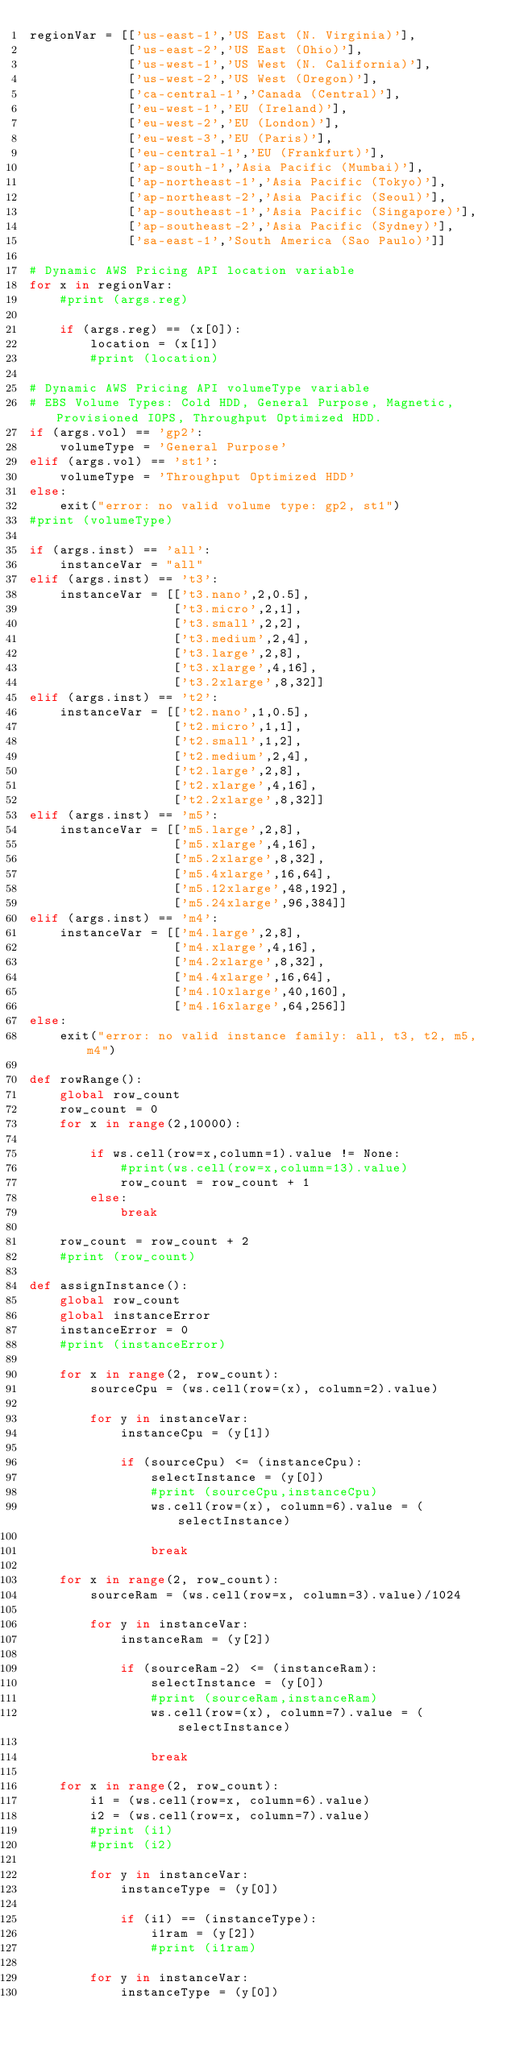<code> <loc_0><loc_0><loc_500><loc_500><_Python_>regionVar = [['us-east-1','US East (N. Virginia)'],
			 ['us-east-2','US East (Ohio)'],
			 ['us-west-1','US West (N. California)'],
			 ['us-west-2','US West (Oregon)'],
			 ['ca-central-1','Canada (Central)'],
			 ['eu-west-1','EU (Ireland)'],
			 ['eu-west-2','EU (London)'],
			 ['eu-west-3','EU (Paris)'],
			 ['eu-central-1','EU (Frankfurt)'],
			 ['ap-south-1','Asia Pacific (Mumbai)'],
			 ['ap-northeast-1','Asia Pacific (Tokyo)'],
			 ['ap-northeast-2','Asia Pacific (Seoul)'],
			 ['ap-southeast-1','Asia Pacific (Singapore)'],
			 ['ap-southeast-2','Asia Pacific (Sydney)'],
			 ['sa-east-1','South America (Sao Paulo)']]

# Dynamic AWS Pricing API location variable
for x in regionVar:
	#print (args.reg)	
	
	if (args.reg) == (x[0]):
		location = (x[1])
		#print (location)
	
# Dynamic AWS Pricing API volumeType variable  
# EBS Volume Types: Cold HDD, General Purpose, Magnetic, Provisioned IOPS, Throughput Optimized HDD.
if (args.vol) == 'gp2':						
	volumeType = 'General Purpose'
elif (args.vol) == 'st1':
	volumeType = 'Throughput Optimized HDD'
else:
	exit("error: no valid volume type: gp2, st1")	
#print (volumeType)

if (args.inst) == 'all':
	instanceVar = "all"
elif (args.inst) == 't3':
	instanceVar = [['t3.nano',2,0.5],
				   ['t3.micro',2,1],
				   ['t3.small',2,2],
				   ['t3.medium',2,4],
				   ['t3.large',2,8],
				   ['t3.xlarge',4,16],
				   ['t3.2xlarge',8,32]]
elif (args.inst) == 't2':
	instanceVar = [['t2.nano',1,0.5],
				   ['t2.micro',1,1],
				   ['t2.small',1,2],
				   ['t2.medium',2,4],
				   ['t2.large',2,8],
				   ['t2.xlarge',4,16],
				   ['t2.2xlarge',8,32]]
elif (args.inst) == 'm5':
	instanceVar = [['m5.large',2,8],
				   ['m5.xlarge',4,16],
				   ['m5.2xlarge',8,32],
				   ['m5.4xlarge',16,64],
				   ['m5.12xlarge',48,192],
				   ['m5.24xlarge',96,384]]
elif (args.inst) == 'm4':
	instanceVar = [['m4.large',2,8],
				   ['m4.xlarge',4,16],
				   ['m4.2xlarge',8,32],
				   ['m4.4xlarge',16,64],
				   ['m4.10xlarge',40,160],
				   ['m4.16xlarge',64,256]]	
else:
	exit("error: no valid instance family: all, t3, t2, m5, m4")

def rowRange():
	global row_count
	row_count = 0
	for x in range(2,10000):
	
		if ws.cell(row=x,column=1).value != None:        
			#print(ws.cell(row=x,column=13).value)
			row_count = row_count + 1
		else: 
			break
	
	row_count = row_count + 2		
	#print (row_count)

def assignInstance():
	global row_count
	global instanceError
	instanceError = 0
	#print (instanceError)
	
	for x in range(2, row_count):
		sourceCpu = (ws.cell(row=(x), column=2).value)
		
		for y in instanceVar:
			instanceCpu = (y[1])
			
			if (sourceCpu) <= (instanceCpu):
				selectInstance = (y[0])
				#print (sourceCpu,instanceCpu)
				ws.cell(row=(x), column=6).value = (selectInstance)
			
				break

	for x in range(2, row_count):
		sourceRam = (ws.cell(row=x, column=3).value)/1024
				
		for y in instanceVar:
			instanceRam = (y[2])
			
			if (sourceRam-2) <= (instanceRam):
				selectInstance = (y[0])
				#print (sourceRam,instanceRam)
				ws.cell(row=(x), column=7).value = (selectInstance)
			
				break
			
	for x in range(2, row_count):
		i1 = (ws.cell(row=x, column=6).value)
		i2 = (ws.cell(row=x, column=7).value)
		#print (i1)
		#print (i2)
		
		for y in instanceVar:
			instanceType = (y[0])
			
			if (i1) == (instanceType):
				i1ram = (y[2])
				#print (i1ram)
		
		for y in instanceVar:
			instanceType = (y[0])			
		</code> 